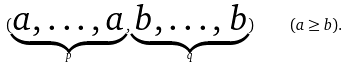<formula> <loc_0><loc_0><loc_500><loc_500>( \underbrace { a , \dots , a } _ { p } , \underbrace { b , \dots , b } _ { q } ) \quad ( a \geq b ) .</formula> 